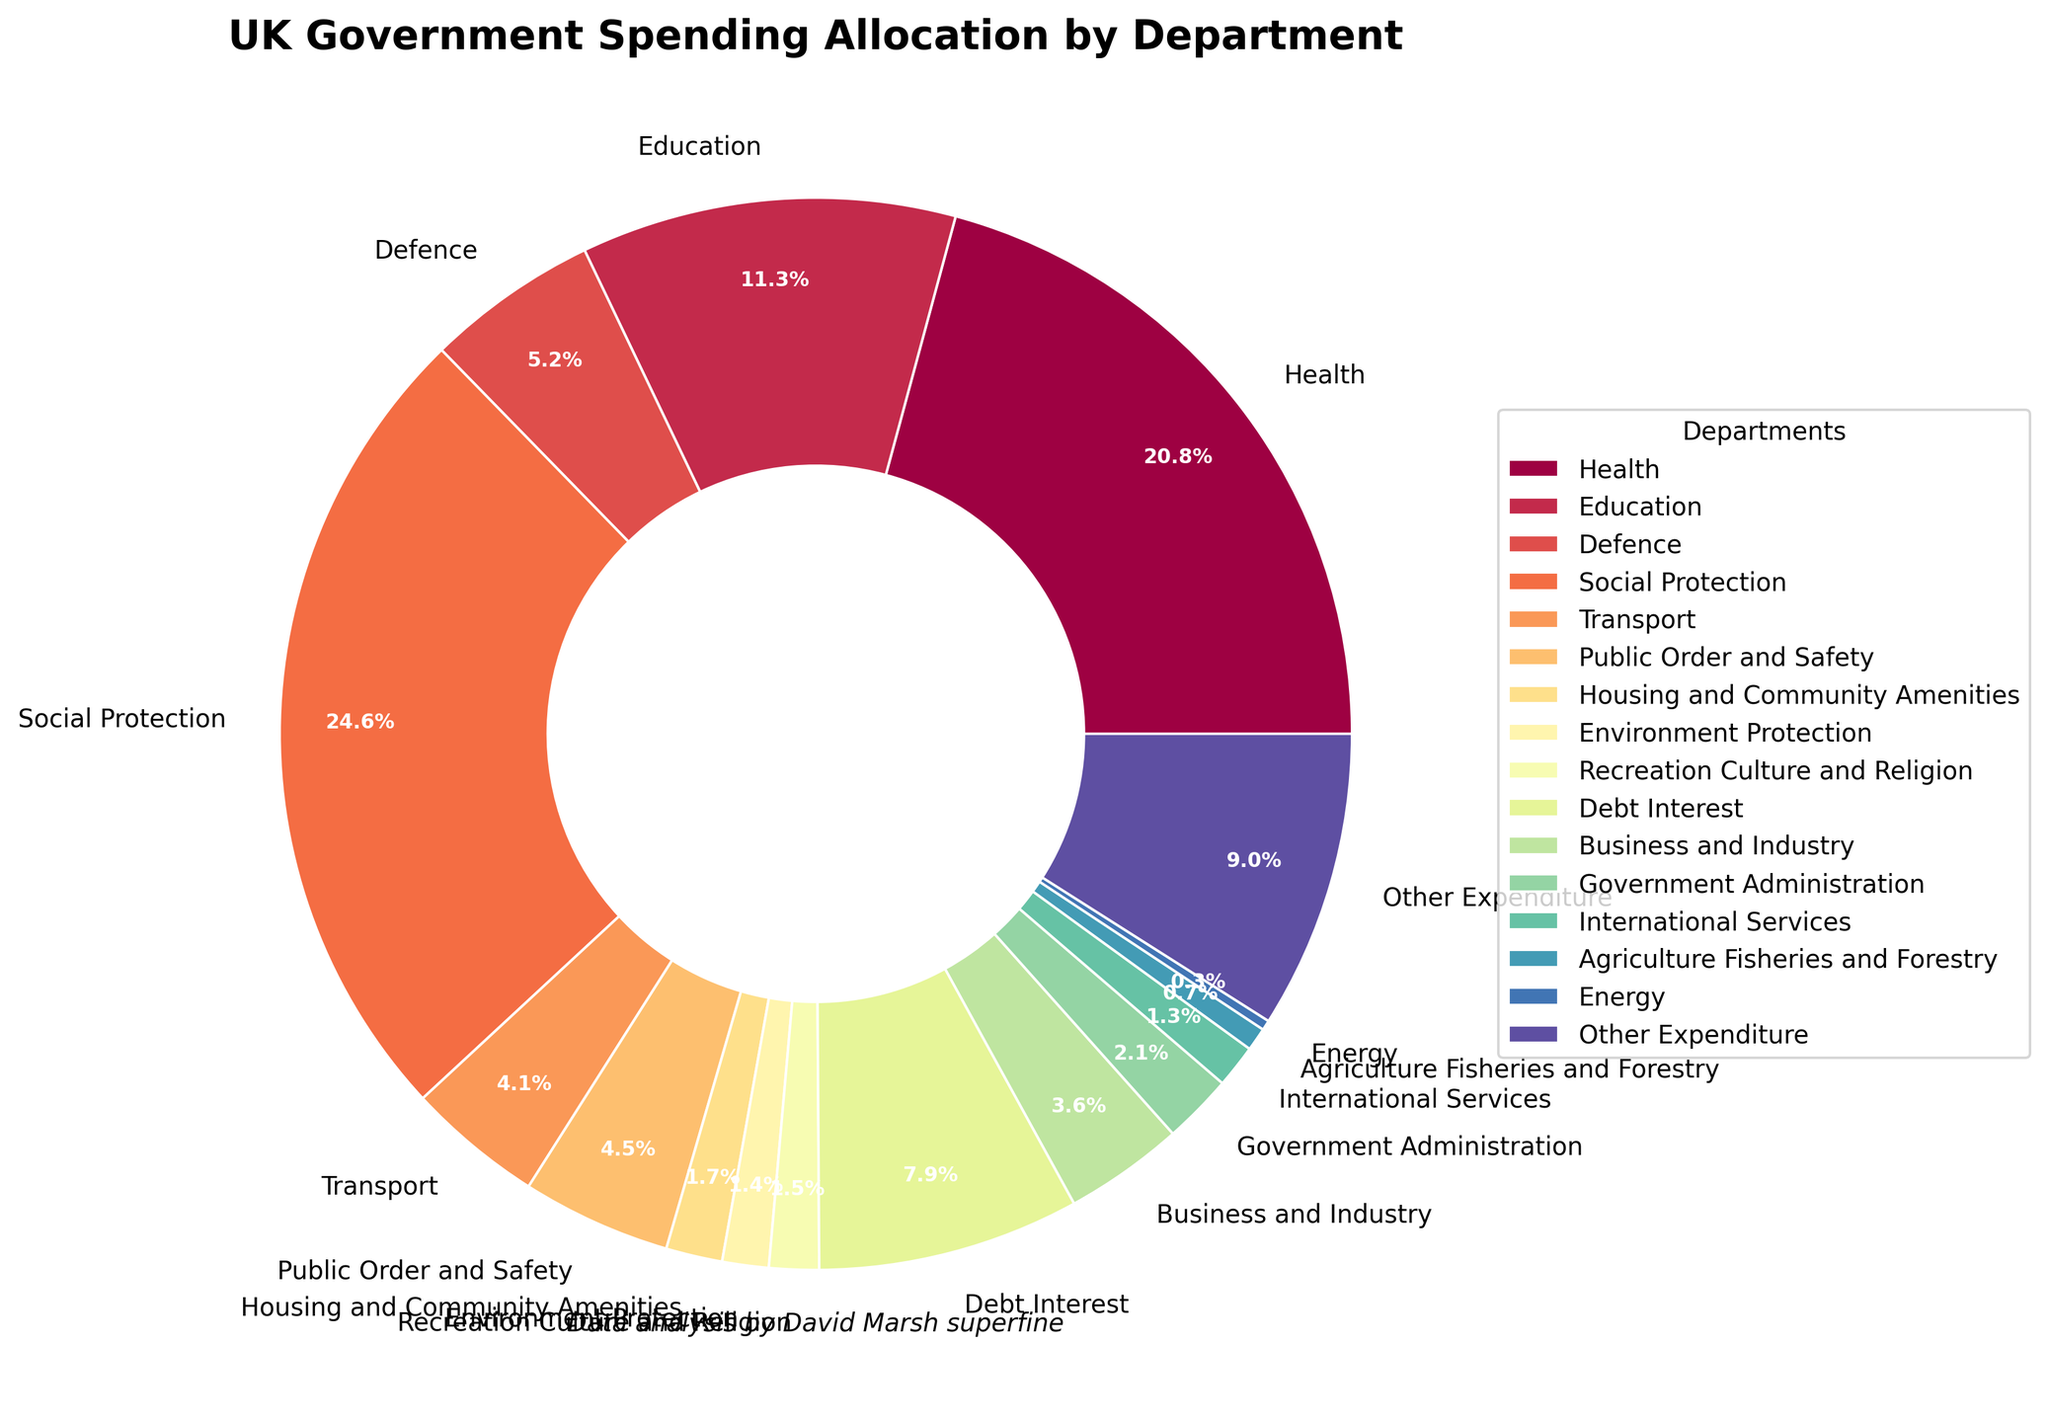Which department receives the highest percentage of government spending? By examining the pie chart, the section with the largest size is for Social Protection.
Answer: Social Protection Which department receives a lower percentage of government spending, Transport or Defence? By comparing the sizes of the slices, Transport is smaller than Defence.
Answer: Transport What is the combined percentage of government spending for Health and Education? Health allocation is 20.8%, and Education is 11.3%. Adding these two together: 20.8% + 11.3% = 32.1%.
Answer: 32.1% How does the percentage of spending on Debt Interest compare to that of Public Order and Safety? By comparing the slices, Debt Interest is larger than Public Order and Safety (7.9% vs. 4.5%).
Answer: Debt Interest is larger Which departments receive less than 2% of the government's spending? By looking at the smaller slices, these are Housing and Community Amenities (1.7%), Environment Protection (1.4%), Recreation Culture and Religion (1.5%), International Services (1.3%), Agriculture Fisheries and Forestry (0.7%), and Energy (0.3%).
Answer: Housing and Community Amenities, Environment Protection, Recreation Culture and Religion, International Services, Agriculture Fisheries and Forestry, Energy If the government decides to double the budget for Transport, what would the new percentage be if the total budget increases accordingly? The current percentage for Transport is 4.1%. Doubling it would make it 4.1% * 2 = 8.2%.
Answer: 8.2% What is the difference between the percentages allocated to Business and Industry and Government Administration? The allocation for Business and Industry is 3.6%, and for Government Administration, it is 2.1%. Subtracting gives: 3.6% - 2.1% = 1.5%.
Answer: 1.5% Which segment has a light blue color? By visually identifying the colors, the light blue section corresponds to the Defence department.
Answer: Defence What is the percentage of spending on departments categorized under Other Expenditure? The Other Expenditure segment is specifically labeled and shows 9.0%.
Answer: 9.0% What is the sum of the percentages allocated to Environment Protection, Agriculture Fisheries and Forestry, and Energy? Adding the percentages: 1.4% + 0.7% + 0.3% = 2.4%.
Answer: 2.4% 